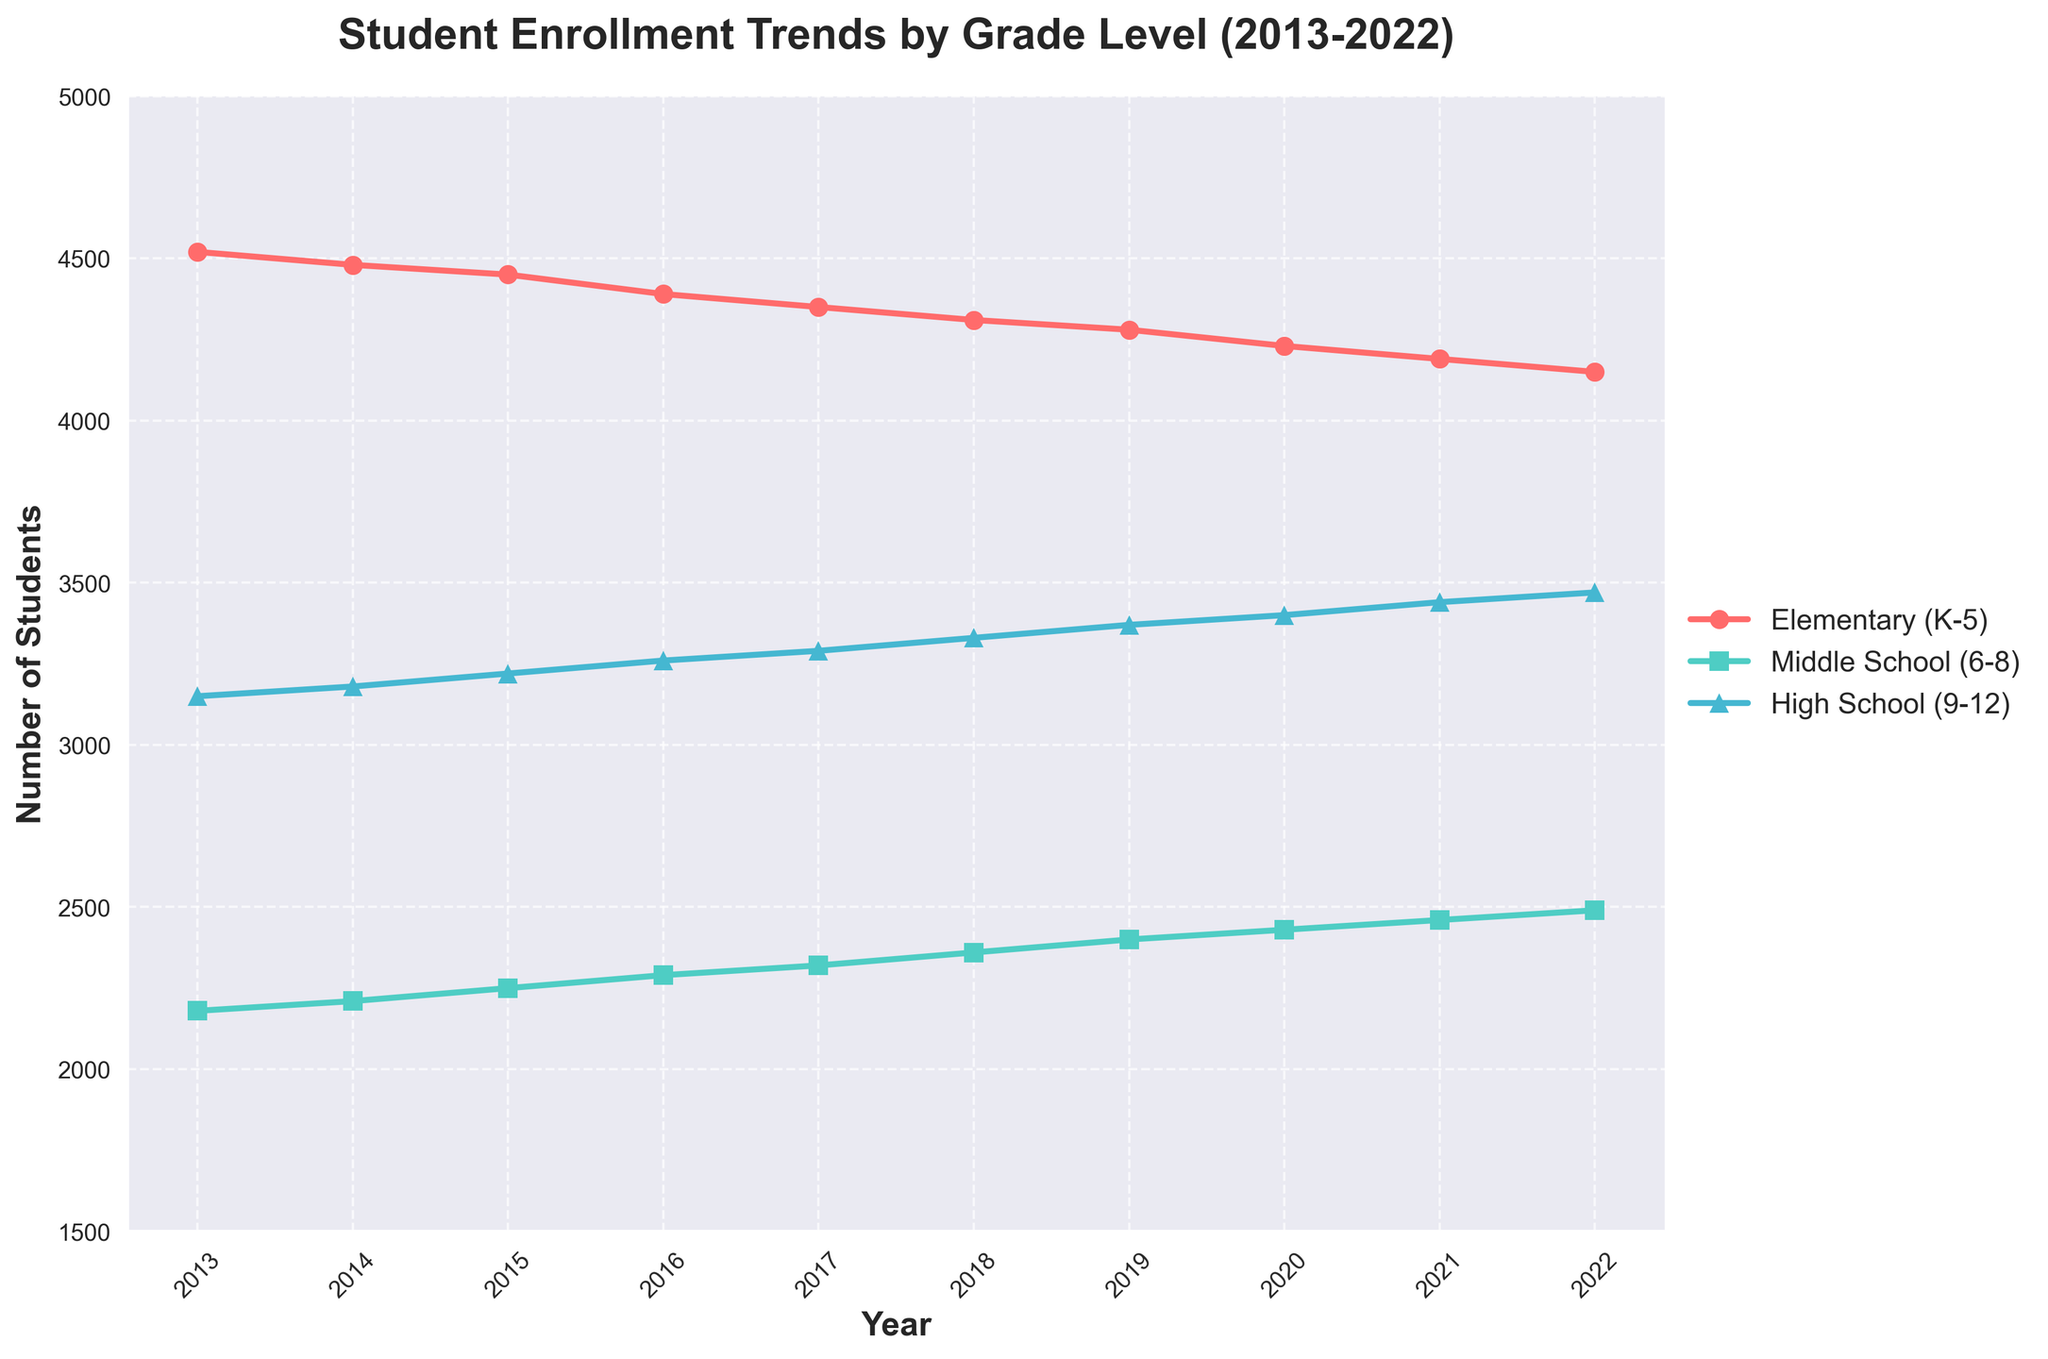What's the enrollment trend for Elementary (K-5) schools over the last decade? Looking at the red line representing Elementary (K-5) schools, there is a gradual decrease in student enrollment from 2013 to 2022. It decreases from 4520 in 2013 to 4150 in 2022.
Answer: Decreasing Which school level has seen the most significant increase in enrollment from 2013 to 2022? By comparing the lines, High School (9-12) has the most significant increase from 3150 in 2013 to 3470 in 2022, an increase of 320 students.
Answer: High School (9-12) What is the total enrollment across all grade levels in the year 2019? Summing the enrollments for 2019: Elementary (4280) + Middle School (2400) + High School (3370) = 4280 + 2400 + 3370 = 10050 students.
Answer: 10050 Between which two years did Middle School (6-8) enrollment increase the most? The green line representing Middle School shows the largest increase of 40 students from 2018 (2360) to 2019 (2400).
Answer: 2018-2019 In 2022, how much higher is High School (9-12) enrollment compared to Elementary (K-5)? Subtracting Elementary (4150) from High School (3470): 3470 - 4150 = 320.
Answer: 320 students On which year did Elementary (K-5) enrollment see the steepest decrease? The steepest decline occurs from 2016 to 2017, with a drop from 4390 to 4350, a decrease of 40 students.
Answer: 2016-2017 What is the average annual enrollment for Middle School (6-8) over the ten years? Summing Middle School enrollments from 2013 to 2022 (2180 + 2210 + 2250 + 2290 + 2320 + 2360 + 2400 + 2430 + 2460 + 2490) and dividing by 10. The sum is 23390, so the average is 23390/10 = 2339 students.
Answer: 2339 students Comparing 2013 and 2022, which grade level experienced the least change in enrollment? By calculating the difference for each grade: Elementary (4520 - 4150 = 370), Middle School (2180 - 2490 = 310), High School (3150 - 3470 = 320). Middle School has the least change of 310 students.
Answer: Middle School (6-8) Which year had the closest enrollment numbers between Elementary (K-5) and Middle School (6-8)? In 2022, Elementary (4150) and Middle School (2490) had a difference of 1660, which is the closest among all years.
Answer: 2022 